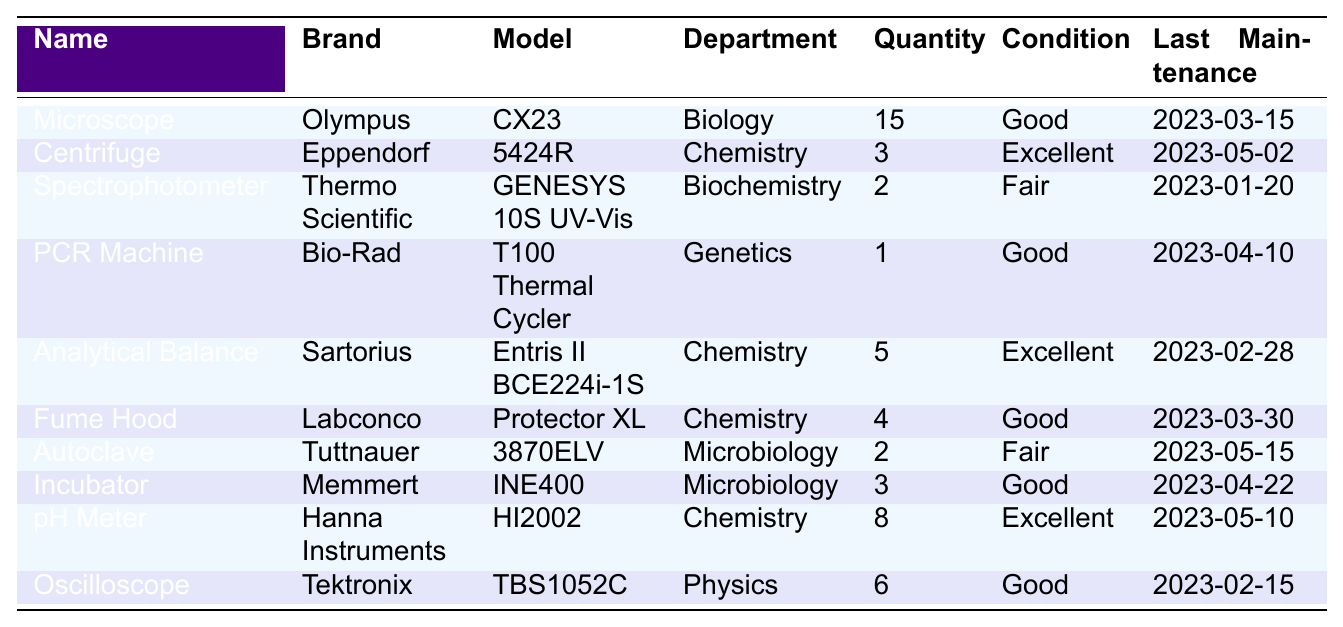What is the quantity of microscopes available in the laboratory? The table lists the microscope under the name section with a quantity of 15.
Answer: 15 Which department has the largest number of items listed? By comparing the quantities of all items in each department, Biology has 15 microscopes, Chemistry has 3 centrifuges, 5 analytical balances, and 8 pH meters (total 16), Biochemistry has 2 spectrophotometers, Genetics has 1 PCR machine, and Microbiology has 2 autoclaves and 3 incubators (total 5). Chemistry has the largest number with a total of 16.
Answer: Chemistry What is the condition of the analytical balance? The condition of the analytical balance is found in its row, which states "Excellent."
Answer: Excellent How many pieces of equipment in the Chemistry department are in good condition? The Chemistry department has three items: 3 centrifuges (Excellent), 5 analytical balances (Excellent), and 4 fume hoods (Good). Only the fume hood is in good condition, giving a total of 1 piece.
Answer: 1 What is the last maintenance date of the PCR machine? The last maintenance date is specified in the table under the last maintenance column for the PCR machine, which is "2023-04-10."
Answer: 2023-04-10 How many pieces of equipment are in fair condition across all departments? The table lists two items in fair condition: 1 spectrophotometer from Biochemistry and 2 autoclaves from Microbiology. Therefore, the total is 1 + 2 = 3 pieces.
Answer: 3 Is there any equipment from the Physics department that is in good condition? The table shows one item from the Physics department, which is an oscilloscope, listed as "Good." Therefore, the answer is yes.
Answer: Yes Which equipment has the most recent maintenance date? The last maintenance dates for equipment range from “2023-05-15” for the autoclave to “2023-01-20” for the spectrophotometer. Comparing these, the autoclave has the most recent date.
Answer: Autoclave What is the total number of equipment items listed in the Chemistry department? Adding the quantities of equipment in Chemistry gives 3 (centrifuge) + 5 (analytical balance) + 4 (fume hood) + 8 (pH meter) = 20 items total.
Answer: 20 Which piece of equipment has the lowest quantity? Looking at the quantities, the PCR machine has only 1 item listed in its row, which is the lowest quantity among all equipment.
Answer: PCR Machine 